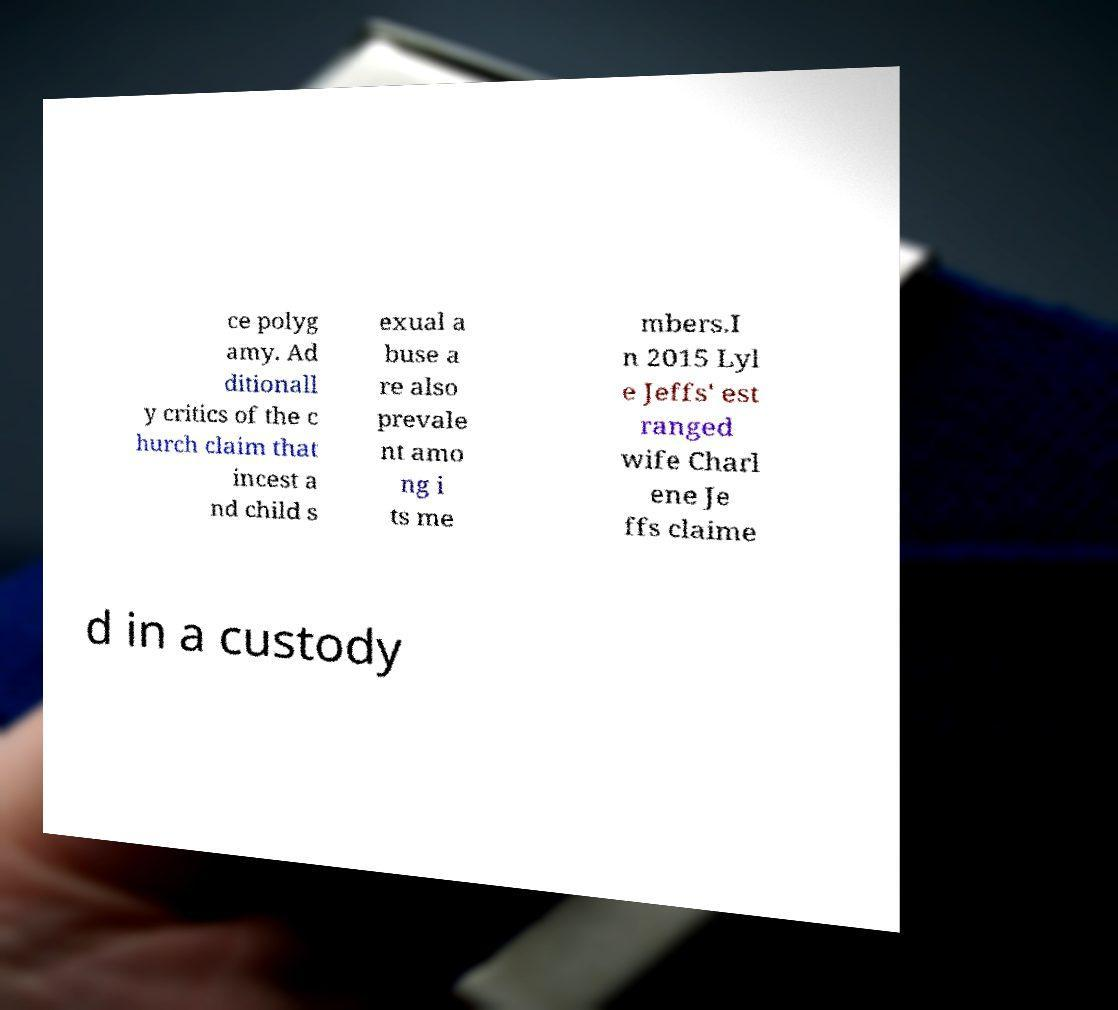Please identify and transcribe the text found in this image. ce polyg amy. Ad ditionall y critics of the c hurch claim that incest a nd child s exual a buse a re also prevale nt amo ng i ts me mbers.I n 2015 Lyl e Jeffs' est ranged wife Charl ene Je ffs claime d in a custody 